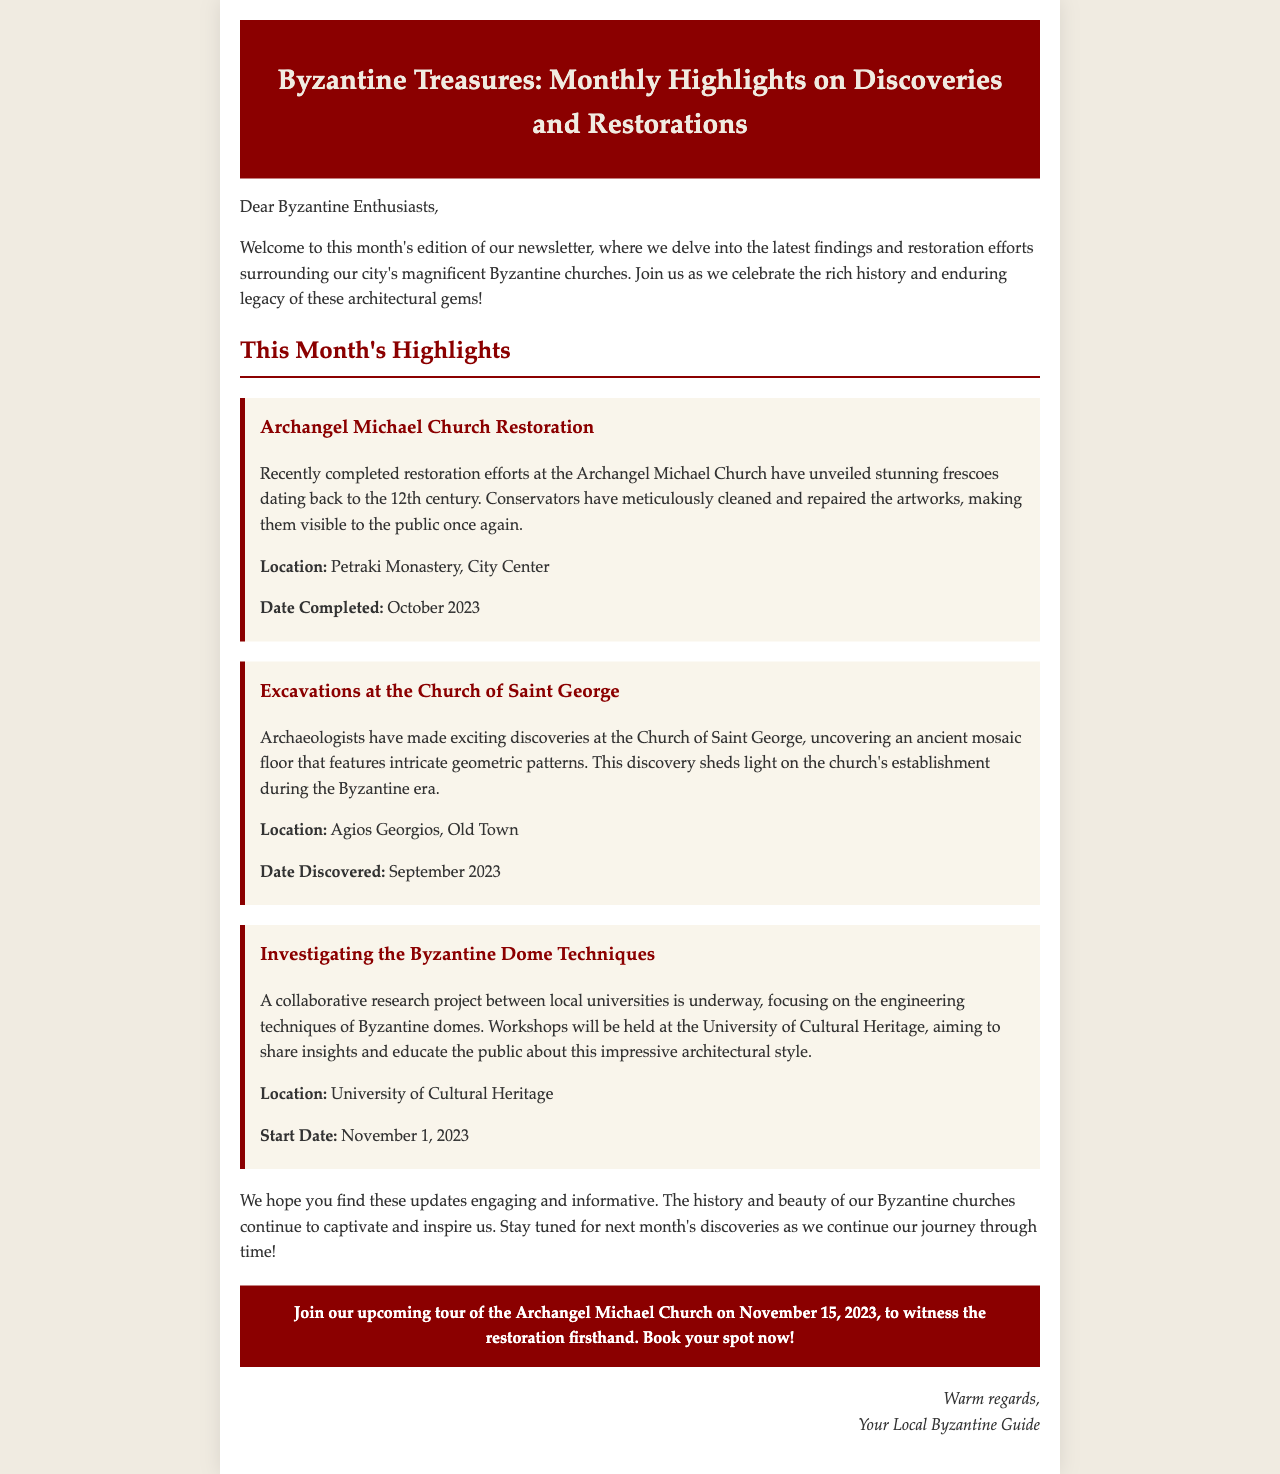what is the title of the newsletter? The title of the newsletter is mentioned at the top of the document.
Answer: Byzantine Treasures: Monthly Highlights on Discoveries and Restorations which church underwent restoration? The church that underwent restoration is directly mentioned in the highlights section.
Answer: Archangel Michael Church what was uncovered during the excavations at the Church of Saint George? The specific finding from the excavations is outlined in the section regarding Saint George.
Answer: ancient mosaic floor when was the restoration of the Archangel Michael Church completed? The completion date of the restoration project is stated in the document.
Answer: October 2023 what is the start date of the workshops at the University of Cultural Heritage? The start date of the workshops focusing on Byzantine dome techniques is provided in the highlights.
Answer: November 1, 2023 where are the workshops about Byzantine dome techniques held? The location of the workshops is specified in the section concerning the research project.
Answer: University of Cultural Heritage when is the upcoming tour of the Archangel Michael Church? The date of the upcoming tour is mentioned in the call-to-action section of the document.
Answer: November 15, 2023 who is the sender of the newsletter? The sender is mentioned in the closing of the newsletter.
Answer: Your Local Byzantine Guide 